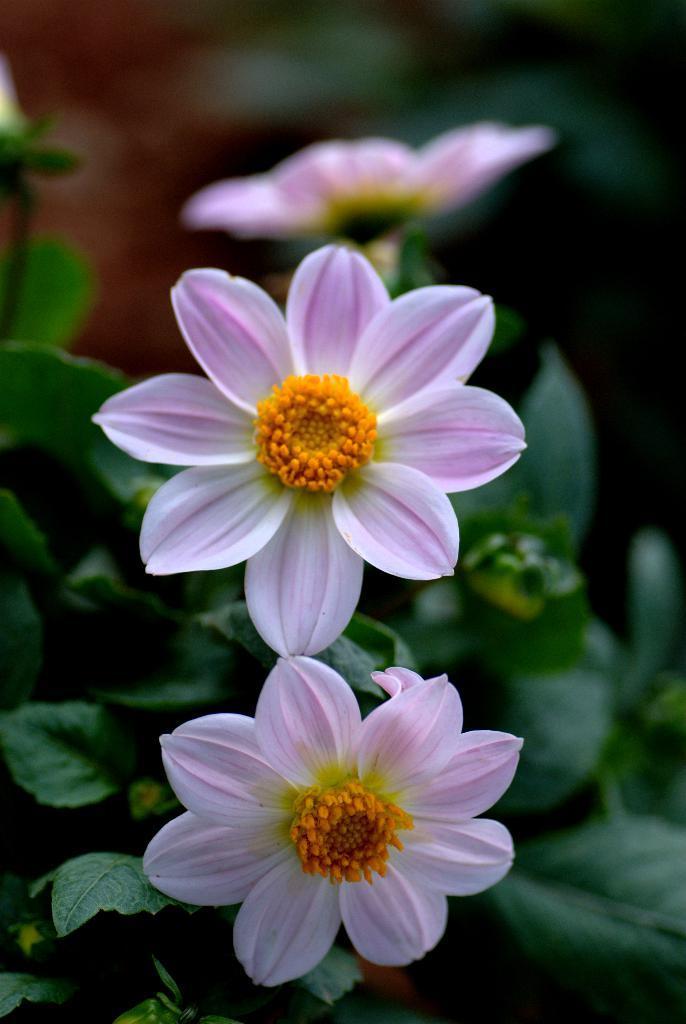How would you summarize this image in a sentence or two? In the picture I can see few flowers which are in violet and white color and there is an orange color object in middle of it and there are few green leaves in the background. 